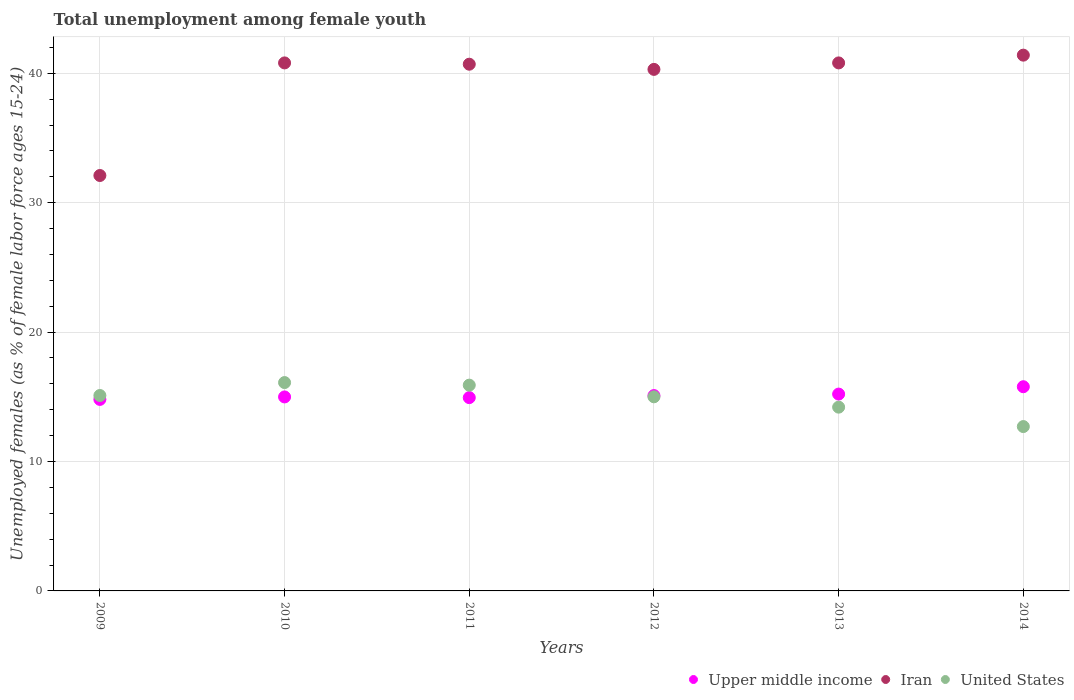How many different coloured dotlines are there?
Your response must be concise. 3. Is the number of dotlines equal to the number of legend labels?
Your answer should be very brief. Yes. What is the percentage of unemployed females in in Upper middle income in 2014?
Make the answer very short. 15.78. Across all years, what is the maximum percentage of unemployed females in in Upper middle income?
Offer a terse response. 15.78. Across all years, what is the minimum percentage of unemployed females in in Upper middle income?
Your answer should be very brief. 14.8. In which year was the percentage of unemployed females in in United States minimum?
Offer a very short reply. 2014. What is the total percentage of unemployed females in in Upper middle income in the graph?
Your response must be concise. 90.81. What is the difference between the percentage of unemployed females in in Upper middle income in 2010 and that in 2011?
Make the answer very short. 0.05. What is the difference between the percentage of unemployed females in in Iran in 2014 and the percentage of unemployed females in in Upper middle income in 2010?
Ensure brevity in your answer.  26.41. What is the average percentage of unemployed females in in Iran per year?
Offer a very short reply. 39.35. In the year 2014, what is the difference between the percentage of unemployed females in in Upper middle income and percentage of unemployed females in in United States?
Your answer should be very brief. 3.08. In how many years, is the percentage of unemployed females in in United States greater than 24 %?
Your response must be concise. 0. What is the ratio of the percentage of unemployed females in in United States in 2012 to that in 2014?
Offer a very short reply. 1.18. Is the difference between the percentage of unemployed females in in Upper middle income in 2011 and 2014 greater than the difference between the percentage of unemployed females in in United States in 2011 and 2014?
Your answer should be compact. No. What is the difference between the highest and the second highest percentage of unemployed females in in United States?
Provide a short and direct response. 0.2. What is the difference between the highest and the lowest percentage of unemployed females in in Iran?
Your answer should be very brief. 9.3. Is it the case that in every year, the sum of the percentage of unemployed females in in United States and percentage of unemployed females in in Upper middle income  is greater than the percentage of unemployed females in in Iran?
Make the answer very short. No. How many dotlines are there?
Your response must be concise. 3. How many years are there in the graph?
Your answer should be very brief. 6. What is the difference between two consecutive major ticks on the Y-axis?
Make the answer very short. 10. Are the values on the major ticks of Y-axis written in scientific E-notation?
Ensure brevity in your answer.  No. Where does the legend appear in the graph?
Your response must be concise. Bottom right. How many legend labels are there?
Offer a very short reply. 3. How are the legend labels stacked?
Your response must be concise. Horizontal. What is the title of the graph?
Keep it short and to the point. Total unemployment among female youth. Does "Antigua and Barbuda" appear as one of the legend labels in the graph?
Keep it short and to the point. No. What is the label or title of the Y-axis?
Offer a terse response. Unemployed females (as % of female labor force ages 15-24). What is the Unemployed females (as % of female labor force ages 15-24) of Upper middle income in 2009?
Offer a terse response. 14.8. What is the Unemployed females (as % of female labor force ages 15-24) of Iran in 2009?
Give a very brief answer. 32.1. What is the Unemployed females (as % of female labor force ages 15-24) of United States in 2009?
Offer a terse response. 15.1. What is the Unemployed females (as % of female labor force ages 15-24) of Upper middle income in 2010?
Your answer should be compact. 14.99. What is the Unemployed females (as % of female labor force ages 15-24) in Iran in 2010?
Give a very brief answer. 40.8. What is the Unemployed females (as % of female labor force ages 15-24) in United States in 2010?
Your response must be concise. 16.1. What is the Unemployed females (as % of female labor force ages 15-24) of Upper middle income in 2011?
Give a very brief answer. 14.94. What is the Unemployed females (as % of female labor force ages 15-24) in Iran in 2011?
Ensure brevity in your answer.  40.7. What is the Unemployed females (as % of female labor force ages 15-24) of United States in 2011?
Ensure brevity in your answer.  15.9. What is the Unemployed females (as % of female labor force ages 15-24) of Upper middle income in 2012?
Offer a terse response. 15.09. What is the Unemployed females (as % of female labor force ages 15-24) of Iran in 2012?
Offer a terse response. 40.3. What is the Unemployed females (as % of female labor force ages 15-24) of Upper middle income in 2013?
Make the answer very short. 15.21. What is the Unemployed females (as % of female labor force ages 15-24) of Iran in 2013?
Make the answer very short. 40.8. What is the Unemployed females (as % of female labor force ages 15-24) of United States in 2013?
Give a very brief answer. 14.2. What is the Unemployed females (as % of female labor force ages 15-24) in Upper middle income in 2014?
Your response must be concise. 15.78. What is the Unemployed females (as % of female labor force ages 15-24) of Iran in 2014?
Ensure brevity in your answer.  41.4. What is the Unemployed females (as % of female labor force ages 15-24) in United States in 2014?
Your answer should be very brief. 12.7. Across all years, what is the maximum Unemployed females (as % of female labor force ages 15-24) in Upper middle income?
Provide a short and direct response. 15.78. Across all years, what is the maximum Unemployed females (as % of female labor force ages 15-24) of Iran?
Give a very brief answer. 41.4. Across all years, what is the maximum Unemployed females (as % of female labor force ages 15-24) of United States?
Ensure brevity in your answer.  16.1. Across all years, what is the minimum Unemployed females (as % of female labor force ages 15-24) in Upper middle income?
Your answer should be very brief. 14.8. Across all years, what is the minimum Unemployed females (as % of female labor force ages 15-24) in Iran?
Provide a short and direct response. 32.1. Across all years, what is the minimum Unemployed females (as % of female labor force ages 15-24) in United States?
Provide a succinct answer. 12.7. What is the total Unemployed females (as % of female labor force ages 15-24) in Upper middle income in the graph?
Give a very brief answer. 90.81. What is the total Unemployed females (as % of female labor force ages 15-24) of Iran in the graph?
Your response must be concise. 236.1. What is the total Unemployed females (as % of female labor force ages 15-24) of United States in the graph?
Make the answer very short. 89. What is the difference between the Unemployed females (as % of female labor force ages 15-24) in Upper middle income in 2009 and that in 2010?
Provide a succinct answer. -0.19. What is the difference between the Unemployed females (as % of female labor force ages 15-24) in United States in 2009 and that in 2010?
Offer a very short reply. -1. What is the difference between the Unemployed females (as % of female labor force ages 15-24) of Upper middle income in 2009 and that in 2011?
Your answer should be very brief. -0.14. What is the difference between the Unemployed females (as % of female labor force ages 15-24) of Iran in 2009 and that in 2011?
Give a very brief answer. -8.6. What is the difference between the Unemployed females (as % of female labor force ages 15-24) of Upper middle income in 2009 and that in 2012?
Provide a succinct answer. -0.3. What is the difference between the Unemployed females (as % of female labor force ages 15-24) in United States in 2009 and that in 2012?
Ensure brevity in your answer.  0.1. What is the difference between the Unemployed females (as % of female labor force ages 15-24) in Upper middle income in 2009 and that in 2013?
Give a very brief answer. -0.41. What is the difference between the Unemployed females (as % of female labor force ages 15-24) of Iran in 2009 and that in 2013?
Your response must be concise. -8.7. What is the difference between the Unemployed females (as % of female labor force ages 15-24) of Upper middle income in 2009 and that in 2014?
Offer a very short reply. -0.98. What is the difference between the Unemployed females (as % of female labor force ages 15-24) in Upper middle income in 2010 and that in 2011?
Your response must be concise. 0.05. What is the difference between the Unemployed females (as % of female labor force ages 15-24) of Iran in 2010 and that in 2011?
Provide a short and direct response. 0.1. What is the difference between the Unemployed females (as % of female labor force ages 15-24) of United States in 2010 and that in 2011?
Your answer should be very brief. 0.2. What is the difference between the Unemployed females (as % of female labor force ages 15-24) in Upper middle income in 2010 and that in 2012?
Keep it short and to the point. -0.1. What is the difference between the Unemployed females (as % of female labor force ages 15-24) of United States in 2010 and that in 2012?
Offer a terse response. 1.1. What is the difference between the Unemployed females (as % of female labor force ages 15-24) in Upper middle income in 2010 and that in 2013?
Provide a short and direct response. -0.22. What is the difference between the Unemployed females (as % of female labor force ages 15-24) in Iran in 2010 and that in 2013?
Give a very brief answer. 0. What is the difference between the Unemployed females (as % of female labor force ages 15-24) of United States in 2010 and that in 2013?
Ensure brevity in your answer.  1.9. What is the difference between the Unemployed females (as % of female labor force ages 15-24) in Upper middle income in 2010 and that in 2014?
Keep it short and to the point. -0.79. What is the difference between the Unemployed females (as % of female labor force ages 15-24) in United States in 2010 and that in 2014?
Give a very brief answer. 3.4. What is the difference between the Unemployed females (as % of female labor force ages 15-24) of Upper middle income in 2011 and that in 2012?
Provide a short and direct response. -0.16. What is the difference between the Unemployed females (as % of female labor force ages 15-24) in United States in 2011 and that in 2012?
Offer a very short reply. 0.9. What is the difference between the Unemployed females (as % of female labor force ages 15-24) in Upper middle income in 2011 and that in 2013?
Your answer should be very brief. -0.27. What is the difference between the Unemployed females (as % of female labor force ages 15-24) of Upper middle income in 2011 and that in 2014?
Give a very brief answer. -0.84. What is the difference between the Unemployed females (as % of female labor force ages 15-24) of Iran in 2011 and that in 2014?
Your answer should be compact. -0.7. What is the difference between the Unemployed females (as % of female labor force ages 15-24) of Upper middle income in 2012 and that in 2013?
Your response must be concise. -0.11. What is the difference between the Unemployed females (as % of female labor force ages 15-24) in United States in 2012 and that in 2013?
Make the answer very short. 0.8. What is the difference between the Unemployed females (as % of female labor force ages 15-24) of Upper middle income in 2012 and that in 2014?
Provide a succinct answer. -0.68. What is the difference between the Unemployed females (as % of female labor force ages 15-24) of Upper middle income in 2013 and that in 2014?
Make the answer very short. -0.57. What is the difference between the Unemployed females (as % of female labor force ages 15-24) in Iran in 2013 and that in 2014?
Provide a short and direct response. -0.6. What is the difference between the Unemployed females (as % of female labor force ages 15-24) in Upper middle income in 2009 and the Unemployed females (as % of female labor force ages 15-24) in Iran in 2010?
Your response must be concise. -26. What is the difference between the Unemployed females (as % of female labor force ages 15-24) in Upper middle income in 2009 and the Unemployed females (as % of female labor force ages 15-24) in United States in 2010?
Offer a terse response. -1.3. What is the difference between the Unemployed females (as % of female labor force ages 15-24) in Upper middle income in 2009 and the Unemployed females (as % of female labor force ages 15-24) in Iran in 2011?
Offer a terse response. -25.9. What is the difference between the Unemployed females (as % of female labor force ages 15-24) of Upper middle income in 2009 and the Unemployed females (as % of female labor force ages 15-24) of United States in 2011?
Give a very brief answer. -1.1. What is the difference between the Unemployed females (as % of female labor force ages 15-24) of Iran in 2009 and the Unemployed females (as % of female labor force ages 15-24) of United States in 2011?
Offer a very short reply. 16.2. What is the difference between the Unemployed females (as % of female labor force ages 15-24) in Upper middle income in 2009 and the Unemployed females (as % of female labor force ages 15-24) in Iran in 2012?
Offer a terse response. -25.5. What is the difference between the Unemployed females (as % of female labor force ages 15-24) in Upper middle income in 2009 and the Unemployed females (as % of female labor force ages 15-24) in United States in 2012?
Your response must be concise. -0.2. What is the difference between the Unemployed females (as % of female labor force ages 15-24) of Upper middle income in 2009 and the Unemployed females (as % of female labor force ages 15-24) of Iran in 2013?
Offer a very short reply. -26. What is the difference between the Unemployed females (as % of female labor force ages 15-24) in Upper middle income in 2009 and the Unemployed females (as % of female labor force ages 15-24) in United States in 2013?
Your answer should be compact. 0.6. What is the difference between the Unemployed females (as % of female labor force ages 15-24) of Upper middle income in 2009 and the Unemployed females (as % of female labor force ages 15-24) of Iran in 2014?
Make the answer very short. -26.6. What is the difference between the Unemployed females (as % of female labor force ages 15-24) in Upper middle income in 2009 and the Unemployed females (as % of female labor force ages 15-24) in United States in 2014?
Your answer should be compact. 2.1. What is the difference between the Unemployed females (as % of female labor force ages 15-24) of Upper middle income in 2010 and the Unemployed females (as % of female labor force ages 15-24) of Iran in 2011?
Offer a terse response. -25.71. What is the difference between the Unemployed females (as % of female labor force ages 15-24) of Upper middle income in 2010 and the Unemployed females (as % of female labor force ages 15-24) of United States in 2011?
Make the answer very short. -0.91. What is the difference between the Unemployed females (as % of female labor force ages 15-24) of Iran in 2010 and the Unemployed females (as % of female labor force ages 15-24) of United States in 2011?
Ensure brevity in your answer.  24.9. What is the difference between the Unemployed females (as % of female labor force ages 15-24) of Upper middle income in 2010 and the Unemployed females (as % of female labor force ages 15-24) of Iran in 2012?
Your answer should be compact. -25.31. What is the difference between the Unemployed females (as % of female labor force ages 15-24) in Upper middle income in 2010 and the Unemployed females (as % of female labor force ages 15-24) in United States in 2012?
Provide a short and direct response. -0.01. What is the difference between the Unemployed females (as % of female labor force ages 15-24) in Iran in 2010 and the Unemployed females (as % of female labor force ages 15-24) in United States in 2012?
Your response must be concise. 25.8. What is the difference between the Unemployed females (as % of female labor force ages 15-24) of Upper middle income in 2010 and the Unemployed females (as % of female labor force ages 15-24) of Iran in 2013?
Make the answer very short. -25.81. What is the difference between the Unemployed females (as % of female labor force ages 15-24) of Upper middle income in 2010 and the Unemployed females (as % of female labor force ages 15-24) of United States in 2013?
Ensure brevity in your answer.  0.79. What is the difference between the Unemployed females (as % of female labor force ages 15-24) in Iran in 2010 and the Unemployed females (as % of female labor force ages 15-24) in United States in 2013?
Offer a terse response. 26.6. What is the difference between the Unemployed females (as % of female labor force ages 15-24) of Upper middle income in 2010 and the Unemployed females (as % of female labor force ages 15-24) of Iran in 2014?
Offer a very short reply. -26.41. What is the difference between the Unemployed females (as % of female labor force ages 15-24) of Upper middle income in 2010 and the Unemployed females (as % of female labor force ages 15-24) of United States in 2014?
Your response must be concise. 2.29. What is the difference between the Unemployed females (as % of female labor force ages 15-24) in Iran in 2010 and the Unemployed females (as % of female labor force ages 15-24) in United States in 2014?
Your answer should be compact. 28.1. What is the difference between the Unemployed females (as % of female labor force ages 15-24) in Upper middle income in 2011 and the Unemployed females (as % of female labor force ages 15-24) in Iran in 2012?
Offer a very short reply. -25.36. What is the difference between the Unemployed females (as % of female labor force ages 15-24) in Upper middle income in 2011 and the Unemployed females (as % of female labor force ages 15-24) in United States in 2012?
Offer a terse response. -0.06. What is the difference between the Unemployed females (as % of female labor force ages 15-24) in Iran in 2011 and the Unemployed females (as % of female labor force ages 15-24) in United States in 2012?
Give a very brief answer. 25.7. What is the difference between the Unemployed females (as % of female labor force ages 15-24) in Upper middle income in 2011 and the Unemployed females (as % of female labor force ages 15-24) in Iran in 2013?
Your answer should be very brief. -25.86. What is the difference between the Unemployed females (as % of female labor force ages 15-24) in Upper middle income in 2011 and the Unemployed females (as % of female labor force ages 15-24) in United States in 2013?
Offer a terse response. 0.74. What is the difference between the Unemployed females (as % of female labor force ages 15-24) of Upper middle income in 2011 and the Unemployed females (as % of female labor force ages 15-24) of Iran in 2014?
Make the answer very short. -26.46. What is the difference between the Unemployed females (as % of female labor force ages 15-24) in Upper middle income in 2011 and the Unemployed females (as % of female labor force ages 15-24) in United States in 2014?
Your answer should be compact. 2.24. What is the difference between the Unemployed females (as % of female labor force ages 15-24) in Iran in 2011 and the Unemployed females (as % of female labor force ages 15-24) in United States in 2014?
Offer a terse response. 28. What is the difference between the Unemployed females (as % of female labor force ages 15-24) in Upper middle income in 2012 and the Unemployed females (as % of female labor force ages 15-24) in Iran in 2013?
Your answer should be compact. -25.71. What is the difference between the Unemployed females (as % of female labor force ages 15-24) of Upper middle income in 2012 and the Unemployed females (as % of female labor force ages 15-24) of United States in 2013?
Your response must be concise. 0.89. What is the difference between the Unemployed females (as % of female labor force ages 15-24) in Iran in 2012 and the Unemployed females (as % of female labor force ages 15-24) in United States in 2013?
Ensure brevity in your answer.  26.1. What is the difference between the Unemployed females (as % of female labor force ages 15-24) of Upper middle income in 2012 and the Unemployed females (as % of female labor force ages 15-24) of Iran in 2014?
Offer a terse response. -26.31. What is the difference between the Unemployed females (as % of female labor force ages 15-24) in Upper middle income in 2012 and the Unemployed females (as % of female labor force ages 15-24) in United States in 2014?
Give a very brief answer. 2.39. What is the difference between the Unemployed females (as % of female labor force ages 15-24) of Iran in 2012 and the Unemployed females (as % of female labor force ages 15-24) of United States in 2014?
Provide a short and direct response. 27.6. What is the difference between the Unemployed females (as % of female labor force ages 15-24) of Upper middle income in 2013 and the Unemployed females (as % of female labor force ages 15-24) of Iran in 2014?
Offer a very short reply. -26.19. What is the difference between the Unemployed females (as % of female labor force ages 15-24) in Upper middle income in 2013 and the Unemployed females (as % of female labor force ages 15-24) in United States in 2014?
Give a very brief answer. 2.51. What is the difference between the Unemployed females (as % of female labor force ages 15-24) in Iran in 2013 and the Unemployed females (as % of female labor force ages 15-24) in United States in 2014?
Your answer should be compact. 28.1. What is the average Unemployed females (as % of female labor force ages 15-24) in Upper middle income per year?
Your response must be concise. 15.13. What is the average Unemployed females (as % of female labor force ages 15-24) of Iran per year?
Provide a short and direct response. 39.35. What is the average Unemployed females (as % of female labor force ages 15-24) of United States per year?
Your answer should be compact. 14.83. In the year 2009, what is the difference between the Unemployed females (as % of female labor force ages 15-24) of Upper middle income and Unemployed females (as % of female labor force ages 15-24) of Iran?
Make the answer very short. -17.3. In the year 2009, what is the difference between the Unemployed females (as % of female labor force ages 15-24) of Upper middle income and Unemployed females (as % of female labor force ages 15-24) of United States?
Offer a terse response. -0.3. In the year 2010, what is the difference between the Unemployed females (as % of female labor force ages 15-24) in Upper middle income and Unemployed females (as % of female labor force ages 15-24) in Iran?
Make the answer very short. -25.81. In the year 2010, what is the difference between the Unemployed females (as % of female labor force ages 15-24) in Upper middle income and Unemployed females (as % of female labor force ages 15-24) in United States?
Keep it short and to the point. -1.11. In the year 2010, what is the difference between the Unemployed females (as % of female labor force ages 15-24) in Iran and Unemployed females (as % of female labor force ages 15-24) in United States?
Your answer should be compact. 24.7. In the year 2011, what is the difference between the Unemployed females (as % of female labor force ages 15-24) in Upper middle income and Unemployed females (as % of female labor force ages 15-24) in Iran?
Your response must be concise. -25.76. In the year 2011, what is the difference between the Unemployed females (as % of female labor force ages 15-24) of Upper middle income and Unemployed females (as % of female labor force ages 15-24) of United States?
Keep it short and to the point. -0.96. In the year 2011, what is the difference between the Unemployed females (as % of female labor force ages 15-24) in Iran and Unemployed females (as % of female labor force ages 15-24) in United States?
Make the answer very short. 24.8. In the year 2012, what is the difference between the Unemployed females (as % of female labor force ages 15-24) of Upper middle income and Unemployed females (as % of female labor force ages 15-24) of Iran?
Your response must be concise. -25.21. In the year 2012, what is the difference between the Unemployed females (as % of female labor force ages 15-24) of Upper middle income and Unemployed females (as % of female labor force ages 15-24) of United States?
Ensure brevity in your answer.  0.09. In the year 2012, what is the difference between the Unemployed females (as % of female labor force ages 15-24) in Iran and Unemployed females (as % of female labor force ages 15-24) in United States?
Make the answer very short. 25.3. In the year 2013, what is the difference between the Unemployed females (as % of female labor force ages 15-24) in Upper middle income and Unemployed females (as % of female labor force ages 15-24) in Iran?
Ensure brevity in your answer.  -25.59. In the year 2013, what is the difference between the Unemployed females (as % of female labor force ages 15-24) in Upper middle income and Unemployed females (as % of female labor force ages 15-24) in United States?
Your answer should be very brief. 1.01. In the year 2013, what is the difference between the Unemployed females (as % of female labor force ages 15-24) in Iran and Unemployed females (as % of female labor force ages 15-24) in United States?
Provide a succinct answer. 26.6. In the year 2014, what is the difference between the Unemployed females (as % of female labor force ages 15-24) of Upper middle income and Unemployed females (as % of female labor force ages 15-24) of Iran?
Your response must be concise. -25.62. In the year 2014, what is the difference between the Unemployed females (as % of female labor force ages 15-24) in Upper middle income and Unemployed females (as % of female labor force ages 15-24) in United States?
Provide a short and direct response. 3.08. In the year 2014, what is the difference between the Unemployed females (as % of female labor force ages 15-24) in Iran and Unemployed females (as % of female labor force ages 15-24) in United States?
Provide a succinct answer. 28.7. What is the ratio of the Unemployed females (as % of female labor force ages 15-24) of Upper middle income in 2009 to that in 2010?
Your answer should be very brief. 0.99. What is the ratio of the Unemployed females (as % of female labor force ages 15-24) in Iran in 2009 to that in 2010?
Make the answer very short. 0.79. What is the ratio of the Unemployed females (as % of female labor force ages 15-24) of United States in 2009 to that in 2010?
Make the answer very short. 0.94. What is the ratio of the Unemployed females (as % of female labor force ages 15-24) in Iran in 2009 to that in 2011?
Offer a very short reply. 0.79. What is the ratio of the Unemployed females (as % of female labor force ages 15-24) in United States in 2009 to that in 2011?
Give a very brief answer. 0.95. What is the ratio of the Unemployed females (as % of female labor force ages 15-24) of Upper middle income in 2009 to that in 2012?
Offer a terse response. 0.98. What is the ratio of the Unemployed females (as % of female labor force ages 15-24) of Iran in 2009 to that in 2012?
Keep it short and to the point. 0.8. What is the ratio of the Unemployed females (as % of female labor force ages 15-24) of Iran in 2009 to that in 2013?
Your answer should be compact. 0.79. What is the ratio of the Unemployed females (as % of female labor force ages 15-24) in United States in 2009 to that in 2013?
Ensure brevity in your answer.  1.06. What is the ratio of the Unemployed females (as % of female labor force ages 15-24) in Upper middle income in 2009 to that in 2014?
Offer a terse response. 0.94. What is the ratio of the Unemployed females (as % of female labor force ages 15-24) in Iran in 2009 to that in 2014?
Your response must be concise. 0.78. What is the ratio of the Unemployed females (as % of female labor force ages 15-24) of United States in 2009 to that in 2014?
Give a very brief answer. 1.19. What is the ratio of the Unemployed females (as % of female labor force ages 15-24) of Iran in 2010 to that in 2011?
Keep it short and to the point. 1. What is the ratio of the Unemployed females (as % of female labor force ages 15-24) in United States in 2010 to that in 2011?
Offer a terse response. 1.01. What is the ratio of the Unemployed females (as % of female labor force ages 15-24) in Iran in 2010 to that in 2012?
Make the answer very short. 1.01. What is the ratio of the Unemployed females (as % of female labor force ages 15-24) of United States in 2010 to that in 2012?
Offer a very short reply. 1.07. What is the ratio of the Unemployed females (as % of female labor force ages 15-24) in Upper middle income in 2010 to that in 2013?
Offer a very short reply. 0.99. What is the ratio of the Unemployed females (as % of female labor force ages 15-24) of Iran in 2010 to that in 2013?
Provide a succinct answer. 1. What is the ratio of the Unemployed females (as % of female labor force ages 15-24) in United States in 2010 to that in 2013?
Provide a succinct answer. 1.13. What is the ratio of the Unemployed females (as % of female labor force ages 15-24) in Iran in 2010 to that in 2014?
Your answer should be compact. 0.99. What is the ratio of the Unemployed females (as % of female labor force ages 15-24) of United States in 2010 to that in 2014?
Your answer should be compact. 1.27. What is the ratio of the Unemployed females (as % of female labor force ages 15-24) of Upper middle income in 2011 to that in 2012?
Keep it short and to the point. 0.99. What is the ratio of the Unemployed females (as % of female labor force ages 15-24) in Iran in 2011 to that in 2012?
Keep it short and to the point. 1.01. What is the ratio of the Unemployed females (as % of female labor force ages 15-24) of United States in 2011 to that in 2012?
Keep it short and to the point. 1.06. What is the ratio of the Unemployed females (as % of female labor force ages 15-24) of Upper middle income in 2011 to that in 2013?
Your response must be concise. 0.98. What is the ratio of the Unemployed females (as % of female labor force ages 15-24) of United States in 2011 to that in 2013?
Offer a very short reply. 1.12. What is the ratio of the Unemployed females (as % of female labor force ages 15-24) of Upper middle income in 2011 to that in 2014?
Provide a short and direct response. 0.95. What is the ratio of the Unemployed females (as % of female labor force ages 15-24) in Iran in 2011 to that in 2014?
Your response must be concise. 0.98. What is the ratio of the Unemployed females (as % of female labor force ages 15-24) in United States in 2011 to that in 2014?
Provide a succinct answer. 1.25. What is the ratio of the Unemployed females (as % of female labor force ages 15-24) in United States in 2012 to that in 2013?
Your answer should be compact. 1.06. What is the ratio of the Unemployed females (as % of female labor force ages 15-24) of Upper middle income in 2012 to that in 2014?
Your answer should be compact. 0.96. What is the ratio of the Unemployed females (as % of female labor force ages 15-24) of Iran in 2012 to that in 2014?
Your answer should be very brief. 0.97. What is the ratio of the Unemployed females (as % of female labor force ages 15-24) of United States in 2012 to that in 2014?
Ensure brevity in your answer.  1.18. What is the ratio of the Unemployed females (as % of female labor force ages 15-24) in Upper middle income in 2013 to that in 2014?
Keep it short and to the point. 0.96. What is the ratio of the Unemployed females (as % of female labor force ages 15-24) of Iran in 2013 to that in 2014?
Make the answer very short. 0.99. What is the ratio of the Unemployed females (as % of female labor force ages 15-24) of United States in 2013 to that in 2014?
Your response must be concise. 1.12. What is the difference between the highest and the second highest Unemployed females (as % of female labor force ages 15-24) of Upper middle income?
Offer a very short reply. 0.57. What is the difference between the highest and the second highest Unemployed females (as % of female labor force ages 15-24) of United States?
Give a very brief answer. 0.2. What is the difference between the highest and the lowest Unemployed females (as % of female labor force ages 15-24) of Upper middle income?
Offer a terse response. 0.98. 